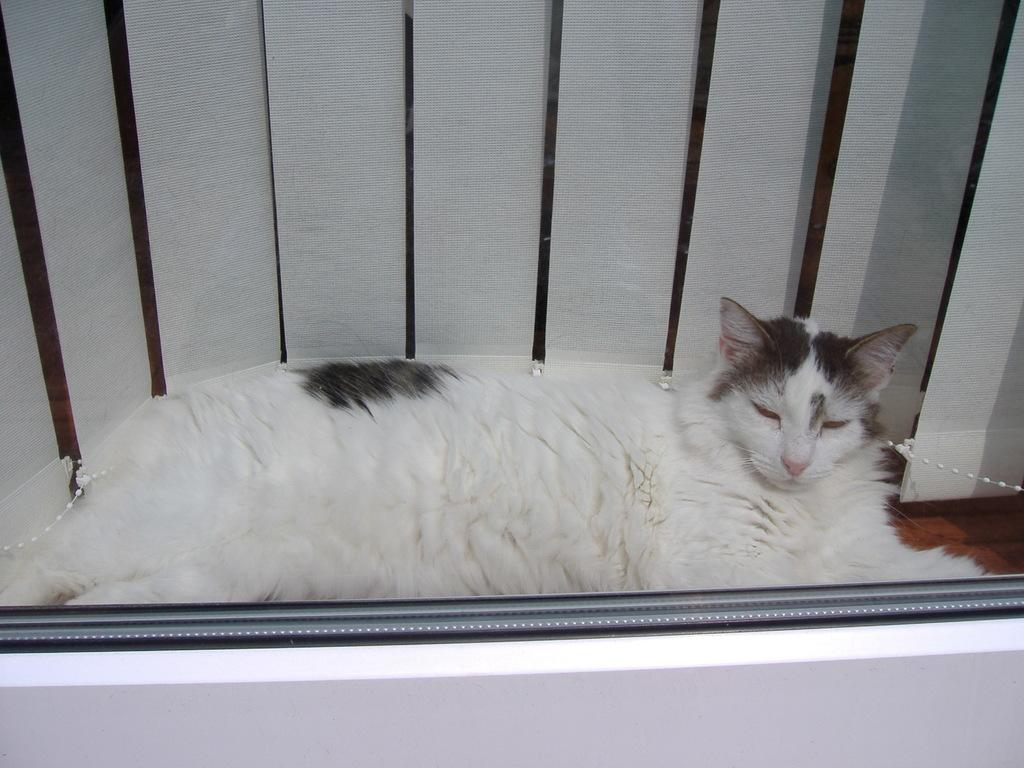What type of animal is in the image? There is a cat in the image. What is the cat doing in the image? The cat is laying down. What colors can be seen on the cat's fur? The cat has white and gray coloring. What can be seen in the background of the image? There is a white color window blind in the background of the image. What emotion is the woman expressing in the image? There is no woman present in the image; it features a cat laying down. 